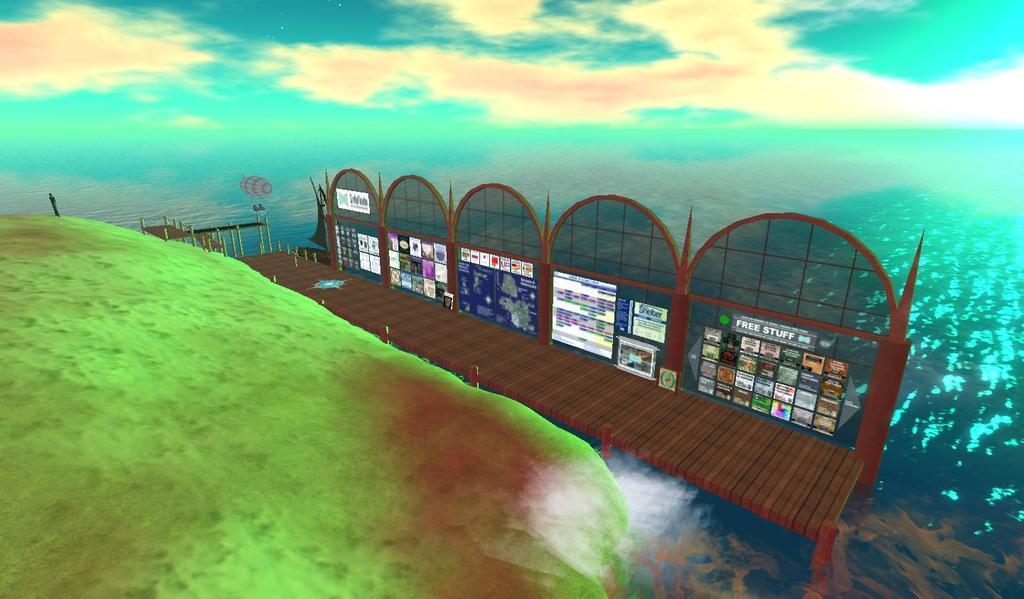Can you describe this image briefly? In this image I can see a bridge,stickers attached to the board,green garden and water. Background is in green,white and blue color. It is an edited image. 